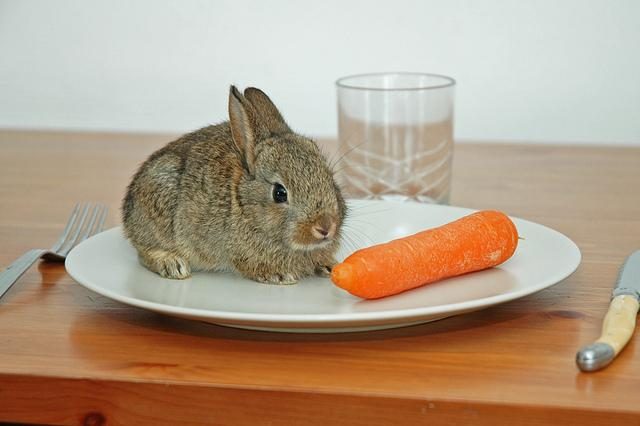What is the rabbit doing on the plate? Please explain your reasoning. eating carrot. He is getting ready to eat a carrot. 